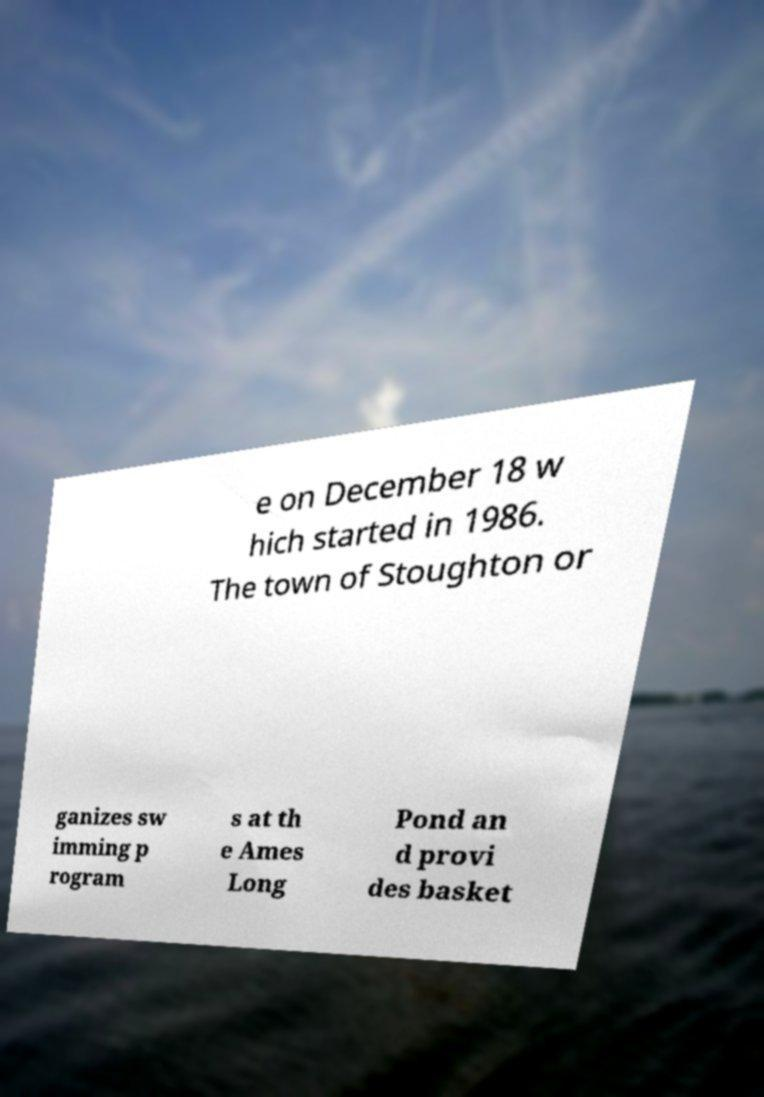For documentation purposes, I need the text within this image transcribed. Could you provide that? e on December 18 w hich started in 1986. The town of Stoughton or ganizes sw imming p rogram s at th e Ames Long Pond an d provi des basket 